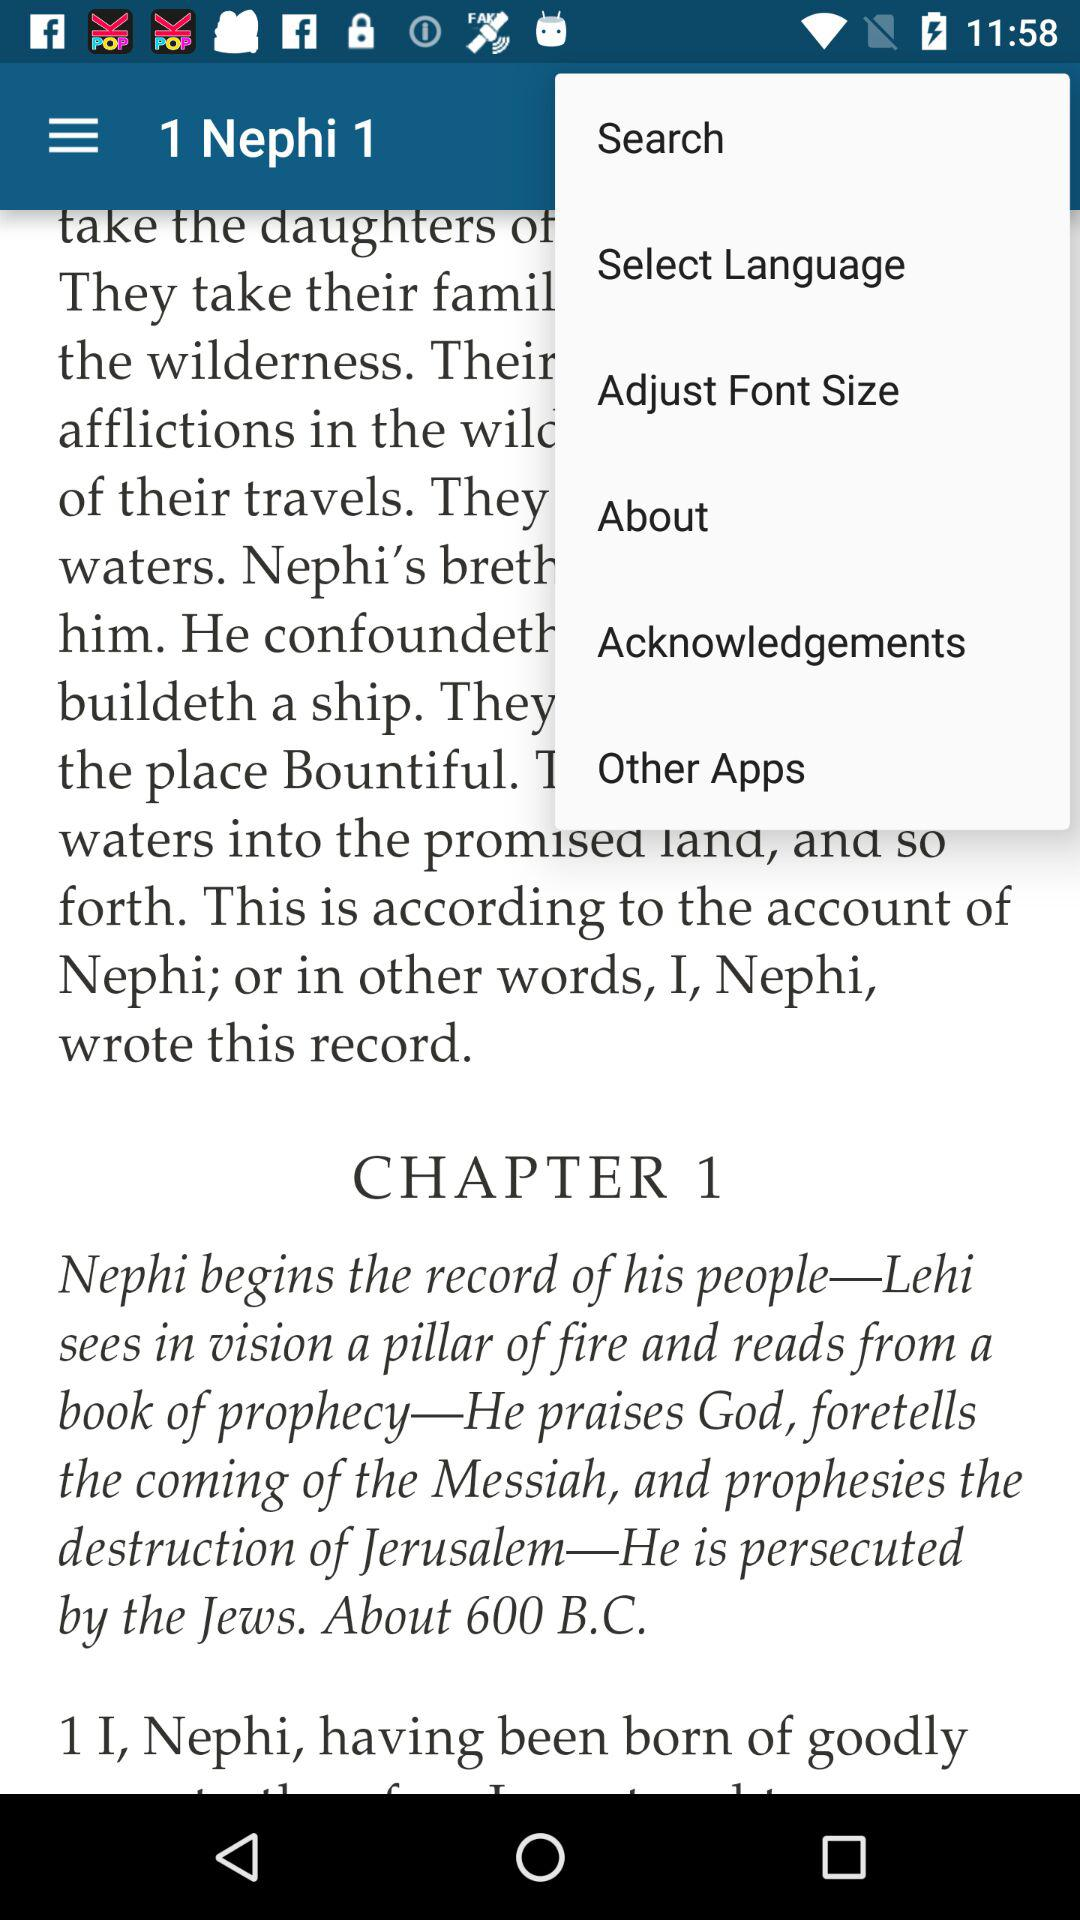How many chapters are in this book?
Answer the question using a single word or phrase. 1 